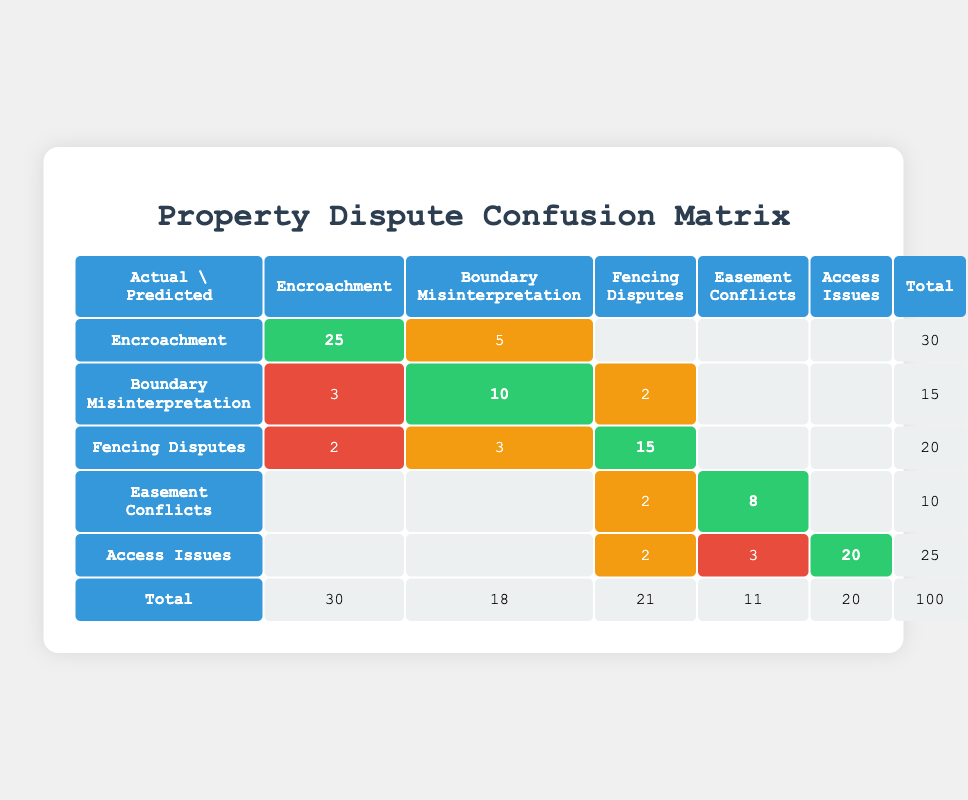What are the actual occurrences of Fencing Disputes? The table shows the total number of actual occurrences for each conflict type in the last row. For Fencing Disputes, it indicates 20 actual cases.
Answer: 20 What is the number of True Positives for Easement Conflicts? By looking at the row for Easement Conflicts, we see the column for True Positives which lists 8 cases.
Answer: 8 Is there a higher occurrence of Access Issues or Boundary Misinterpretation? The actual occurrences for Access Issues is 25, while Boundary Misinterpretation has 15. Therefore, Access Issues has a higher occurrence.
Answer: Yes What is the total number of False Negatives across all conflict types? To find the total False Negatives, we sum up the False Negatives from each type: 5 (Encroachment) + 5 (Boundary Misinterpretation) + 3 (Fencing Disputes) + 2 (Easement Conflicts) + 2 (Access Issues) = 17.
Answer: 17 What is the difference between the True Positives for Encroachment and Fencing Disputes? The True Positives for Encroachment is 25 and for Fencing Disputes it is 15. The difference is 25 - 15 = 10.
Answer: 10 What percentage of the total occurrences are related to Encroachment? The total occurrences of all conflict types is 100. Encroachment has 30 occurrences. The percentage is (30/100)*100 = 30%.
Answer: 30% Which type has the most False Positives? By examining the False Positives in each row, Access Issues has 3, Boundary Misinterpretation has 3, Fencing Disputes has 2, Easement Conflicts has 1, and Encroachment has 5. Therefore, Encroachment has the most.
Answer: Encroachment How many more True Positives are there for Access Issues compared to Easement Conflicts? Access Issues has 20 True Positives, and Easement Conflicts has 8. The difference is 20 - 8 = 12.
Answer: 12 What is the total number of predicted occurrences for Fencing Disputes? To calculate the total predicted occurrences, we add True Positives, False Positives, and False Negatives for Fencing Disputes: 15 + 2 + 3 = 20.
Answer: 20 